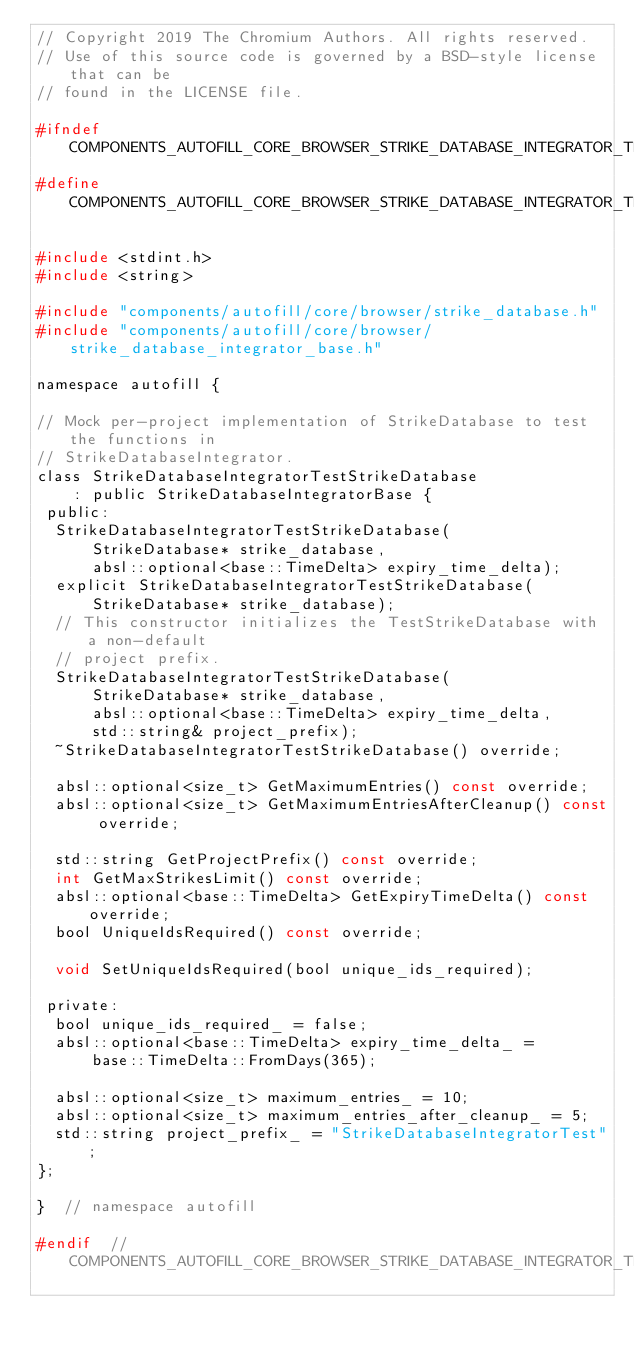<code> <loc_0><loc_0><loc_500><loc_500><_C_>// Copyright 2019 The Chromium Authors. All rights reserved.
// Use of this source code is governed by a BSD-style license that can be
// found in the LICENSE file.

#ifndef COMPONENTS_AUTOFILL_CORE_BROWSER_STRIKE_DATABASE_INTEGRATOR_TEST_STRIKE_DATABASE_H_
#define COMPONENTS_AUTOFILL_CORE_BROWSER_STRIKE_DATABASE_INTEGRATOR_TEST_STRIKE_DATABASE_H_

#include <stdint.h>
#include <string>

#include "components/autofill/core/browser/strike_database.h"
#include "components/autofill/core/browser/strike_database_integrator_base.h"

namespace autofill {

// Mock per-project implementation of StrikeDatabase to test the functions in
// StrikeDatabaseIntegrator.
class StrikeDatabaseIntegratorTestStrikeDatabase
    : public StrikeDatabaseIntegratorBase {
 public:
  StrikeDatabaseIntegratorTestStrikeDatabase(
      StrikeDatabase* strike_database,
      absl::optional<base::TimeDelta> expiry_time_delta);
  explicit StrikeDatabaseIntegratorTestStrikeDatabase(
      StrikeDatabase* strike_database);
  // This constructor initializes the TestStrikeDatabase with a non-default
  // project prefix.
  StrikeDatabaseIntegratorTestStrikeDatabase(
      StrikeDatabase* strike_database,
      absl::optional<base::TimeDelta> expiry_time_delta,
      std::string& project_prefix);
  ~StrikeDatabaseIntegratorTestStrikeDatabase() override;

  absl::optional<size_t> GetMaximumEntries() const override;
  absl::optional<size_t> GetMaximumEntriesAfterCleanup() const override;

  std::string GetProjectPrefix() const override;
  int GetMaxStrikesLimit() const override;
  absl::optional<base::TimeDelta> GetExpiryTimeDelta() const override;
  bool UniqueIdsRequired() const override;

  void SetUniqueIdsRequired(bool unique_ids_required);

 private:
  bool unique_ids_required_ = false;
  absl::optional<base::TimeDelta> expiry_time_delta_ =
      base::TimeDelta::FromDays(365);

  absl::optional<size_t> maximum_entries_ = 10;
  absl::optional<size_t> maximum_entries_after_cleanup_ = 5;
  std::string project_prefix_ = "StrikeDatabaseIntegratorTest";
};

}  // namespace autofill

#endif  // COMPONENTS_AUTOFILL_CORE_BROWSER_STRIKE_DATABASE_INTEGRATOR_TEST_STRIKE_DATABASE_H_
</code> 